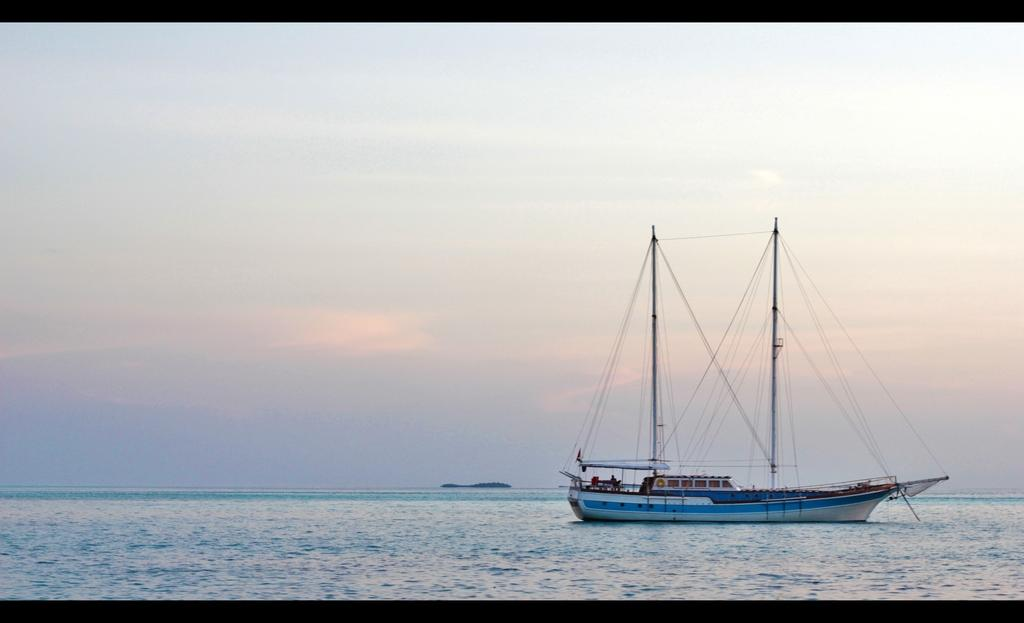What is the main setting or location depicted in the image? There is a sea in the image. What is present on the sea in the image? There is a ship sailing on the sea in the image. What type of fang can be seen on the ship in the image? There is no fang present on the ship in the image. What type of cap is the ship wearing in the image? Ships do not wear caps, so this question cannot be answered definitively from the image. 